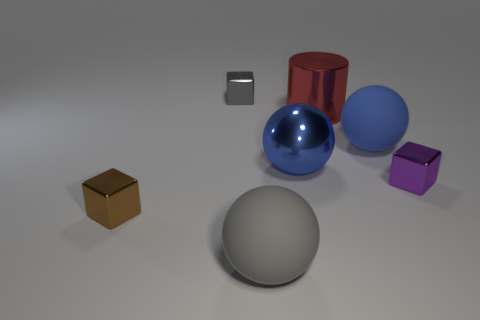Add 2 yellow shiny spheres. How many objects exist? 9 Subtract all blocks. How many objects are left? 4 Subtract all brown objects. Subtract all small brown metallic objects. How many objects are left? 5 Add 6 tiny brown metallic cubes. How many tiny brown metallic cubes are left? 7 Add 4 matte objects. How many matte objects exist? 6 Subtract 0 gray cylinders. How many objects are left? 7 